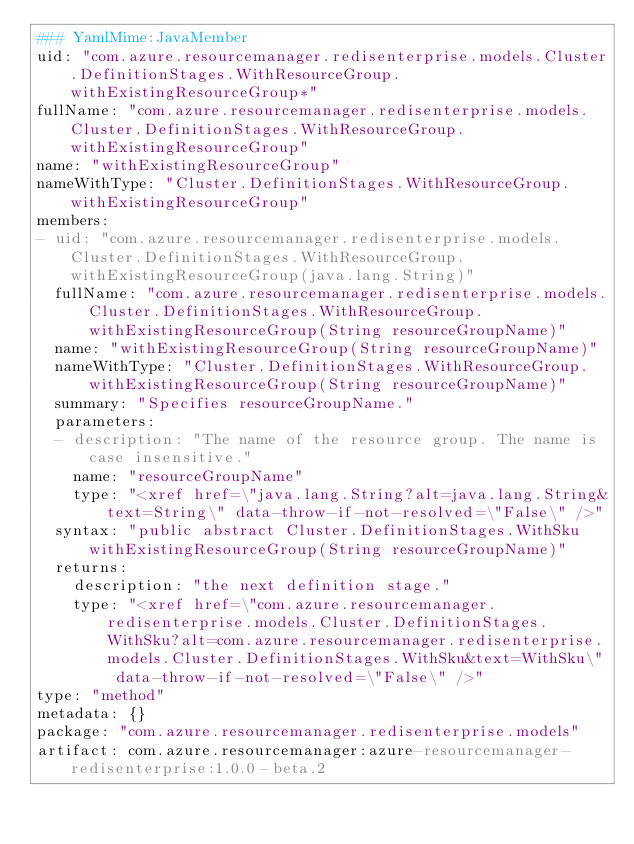<code> <loc_0><loc_0><loc_500><loc_500><_YAML_>### YamlMime:JavaMember
uid: "com.azure.resourcemanager.redisenterprise.models.Cluster.DefinitionStages.WithResourceGroup.withExistingResourceGroup*"
fullName: "com.azure.resourcemanager.redisenterprise.models.Cluster.DefinitionStages.WithResourceGroup.withExistingResourceGroup"
name: "withExistingResourceGroup"
nameWithType: "Cluster.DefinitionStages.WithResourceGroup.withExistingResourceGroup"
members:
- uid: "com.azure.resourcemanager.redisenterprise.models.Cluster.DefinitionStages.WithResourceGroup.withExistingResourceGroup(java.lang.String)"
  fullName: "com.azure.resourcemanager.redisenterprise.models.Cluster.DefinitionStages.WithResourceGroup.withExistingResourceGroup(String resourceGroupName)"
  name: "withExistingResourceGroup(String resourceGroupName)"
  nameWithType: "Cluster.DefinitionStages.WithResourceGroup.withExistingResourceGroup(String resourceGroupName)"
  summary: "Specifies resourceGroupName."
  parameters:
  - description: "The name of the resource group. The name is case insensitive."
    name: "resourceGroupName"
    type: "<xref href=\"java.lang.String?alt=java.lang.String&text=String\" data-throw-if-not-resolved=\"False\" />"
  syntax: "public abstract Cluster.DefinitionStages.WithSku withExistingResourceGroup(String resourceGroupName)"
  returns:
    description: "the next definition stage."
    type: "<xref href=\"com.azure.resourcemanager.redisenterprise.models.Cluster.DefinitionStages.WithSku?alt=com.azure.resourcemanager.redisenterprise.models.Cluster.DefinitionStages.WithSku&text=WithSku\" data-throw-if-not-resolved=\"False\" />"
type: "method"
metadata: {}
package: "com.azure.resourcemanager.redisenterprise.models"
artifact: com.azure.resourcemanager:azure-resourcemanager-redisenterprise:1.0.0-beta.2
</code> 